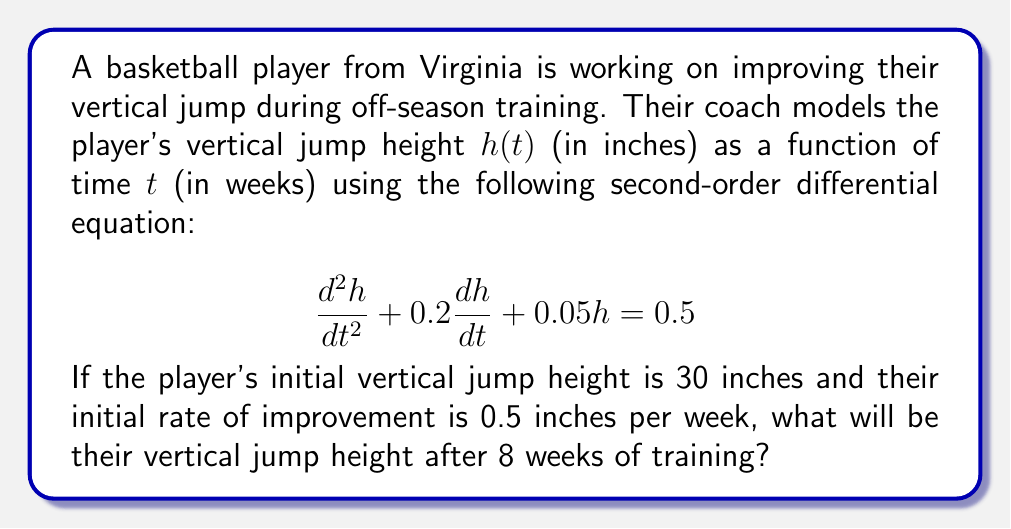Provide a solution to this math problem. To solve this problem, we need to follow these steps:

1) First, we identify this as a non-homogeneous second-order linear differential equation with constant coefficients.

2) The general solution will be the sum of the complementary function (solution to the homogeneous equation) and the particular integral (a solution to the full equation).

3) For the complementary function, we solve the characteristic equation:
   $$r^2 + 0.2r + 0.05 = 0$$
   Using the quadratic formula, we get:
   $$r = \frac{-0.2 \pm \sqrt{0.04 - 0.2}}{2} = -0.1 \pm 0.2i$$

4) Therefore, the complementary function is:
   $$h_c(t) = e^{-0.1t}(A\cos(0.2t) + B\sin(0.2t))$$

5) For the particular integral, since the right-hand side is a constant, we guess a constant solution:
   $$h_p(t) = C$$
   Substituting this into the original equation:
   $$0 + 0 + 0.05C = 0.5$$
   $$C = 10$$

6) The general solution is thus:
   $$h(t) = e^{-0.1t}(A\cos(0.2t) + B\sin(0.2t)) + 10$$

7) Now we use the initial conditions to find A and B:
   At $t=0$, $h(0) = 30$ and $h'(0) = 0.5$

8) From $h(0) = 30$:
   $$30 = A + 10$$
   $$A = 20$$

9) From $h'(0) = 0.5$:
   $$0.5 = -0.1A + 0.2B$$
   $$0.5 = -2 + 0.2B$$
   $$B = 12.5$$

10) Therefore, the particular solution is:
    $$h(t) = e^{-0.1t}(20\cos(0.2t) + 12.5\sin(0.2t)) + 10$$

11) To find the height after 8 weeks, we substitute $t=8$:
    $$h(8) = e^{-0.8}(20\cos(1.6) + 12.5\sin(1.6)) + 10$$

12) Calculating this gives us the final answer.
Answer: The player's vertical jump height after 8 weeks of training will be approximately 35.47 inches. 